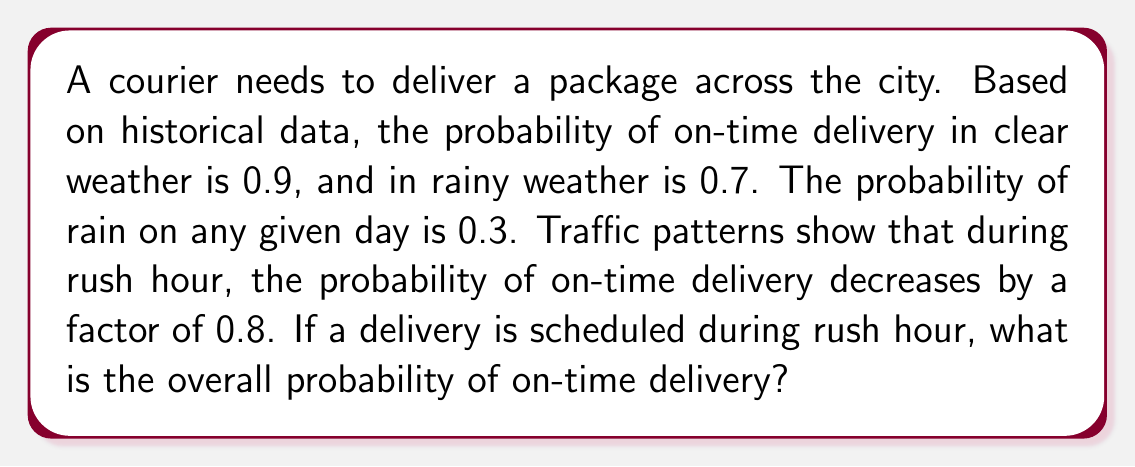Provide a solution to this math problem. Let's approach this step-by-step using the law of total probability:

1) Let's define our events:
   A: On-time delivery
   R: Rainy weather
   C: Clear weather

2) We're given:
   P(A|C) = 0.9 (probability of on-time delivery in clear weather)
   P(A|R) = 0.7 (probability of on-time delivery in rainy weather)
   P(R) = 0.3 (probability of rain)
   P(C) = 1 - P(R) = 0.7 (probability of clear weather)

3) The law of total probability states:
   P(A) = P(A|C) * P(C) + P(A|R) * P(R)

4) Substituting our values:
   P(A) = 0.9 * 0.7 + 0.7 * 0.3 = 0.63 + 0.21 = 0.84

5) However, this is during normal conditions. During rush hour, the probability decreases by a factor of 0.8:

   P(A_rush) = 0.84 * 0.8 = 0.672

6) Therefore, the overall probability of on-time delivery during rush hour is 0.672 or 67.2%.

This can be expressed mathematically as:

$$ P(A_\text{rush}) = (P(A|C) \cdot P(C) + P(A|R) \cdot P(R)) \cdot 0.8 $$
$$ = (0.9 \cdot 0.7 + 0.7 \cdot 0.3) \cdot 0.8 = 0.672 $$
Answer: 0.672 